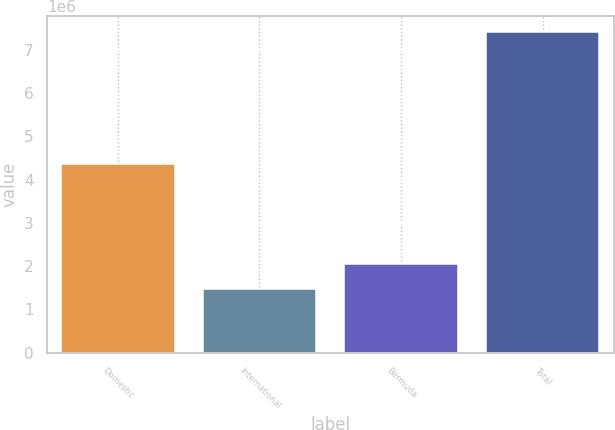Convert chart to OTSL. <chart><loc_0><loc_0><loc_500><loc_500><bar_chart><fcel>Domestic<fcel>International<fcel>Bermuda<fcel>Total<nl><fcel>4.35016e+06<fcel>1.45874e+06<fcel>2.05431e+06<fcel>7.41443e+06<nl></chart> 